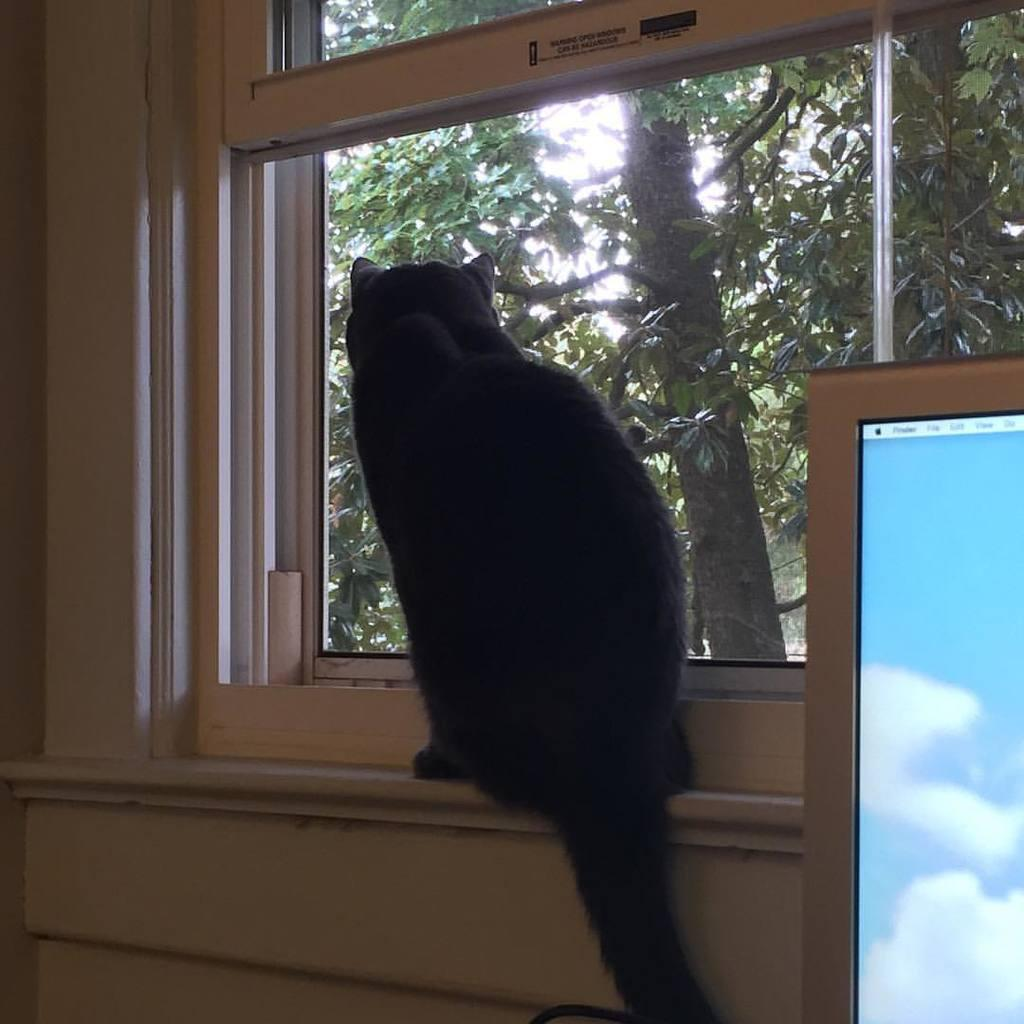What is the main subject in the center of the image? There is a cat in the center of the image. What is in front of the cat? There is a glass window in front of the cat. What can be seen through the glass window? Trees are visible through the glass window. What electronic device is on the right side of the image? There is a computer on the right side of the image. What type of disease is the cat suffering from in the image? There is no indication in the image that the cat is suffering from any disease. How many things can be seen in the image? It is not possible to determine the exact number of things in the image, as the term "things" is too vague. However, we can identify specific objects, such as the cat, glass window, trees, and computer. 